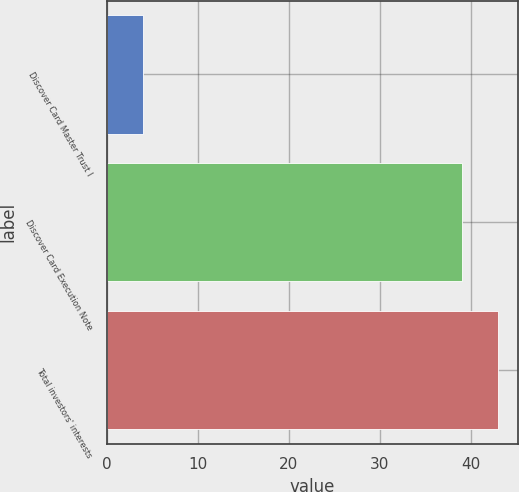Convert chart to OTSL. <chart><loc_0><loc_0><loc_500><loc_500><bar_chart><fcel>Discover Card Master Trust I<fcel>Discover Card Execution Note<fcel>Total investors' interests<nl><fcel>4<fcel>39<fcel>43<nl></chart> 